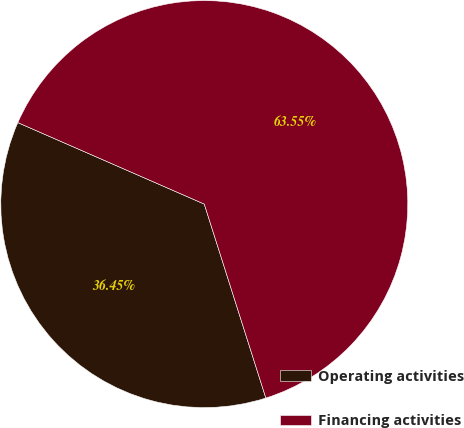Convert chart. <chart><loc_0><loc_0><loc_500><loc_500><pie_chart><fcel>Operating activities<fcel>Financing activities<nl><fcel>36.45%<fcel>63.55%<nl></chart> 